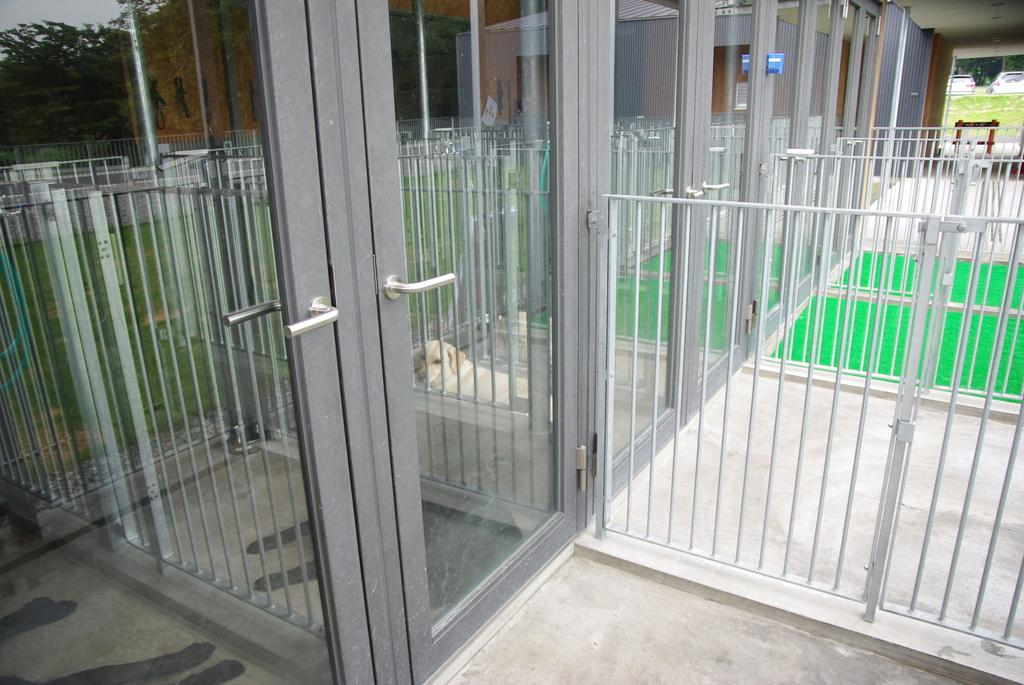What type of structure is present in the image? There is a door in the image. Is there any additional security feature visible in the image? Yes, there is a safety grill in the image. What type of animal can be seen in the image? There is a dog in the image. What type of nail is the judge using to hang a painting in the image? There is no judge or painting present in the image, and therefore no nail can be observed. 